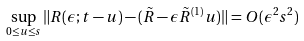<formula> <loc_0><loc_0><loc_500><loc_500>\sup _ { 0 \leq u \leq s } \| R ( \epsilon ; t - u ) - ( \tilde { R } - \epsilon \tilde { R } ^ { ( 1 ) } u ) \| = O ( \epsilon ^ { 2 } s ^ { 2 } )</formula> 